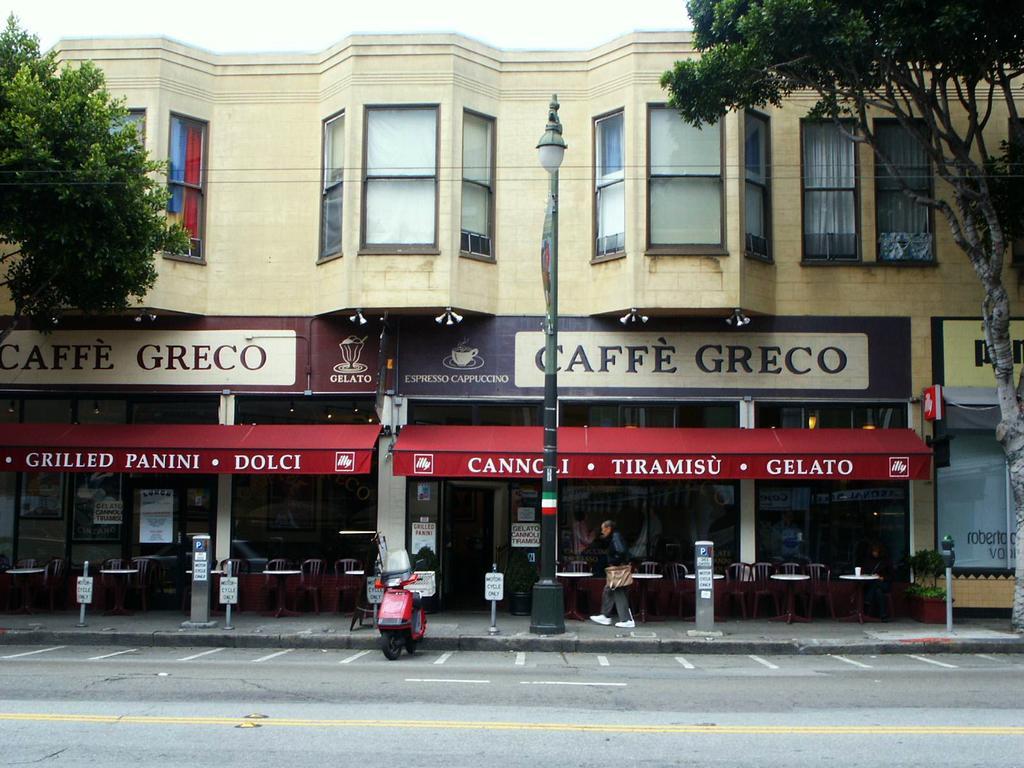Please provide a concise description of this image. In the image there is a person standing in front of a building and in the front there is a road and a bike in the middle of it, there are trees on either sides and above its sky. 